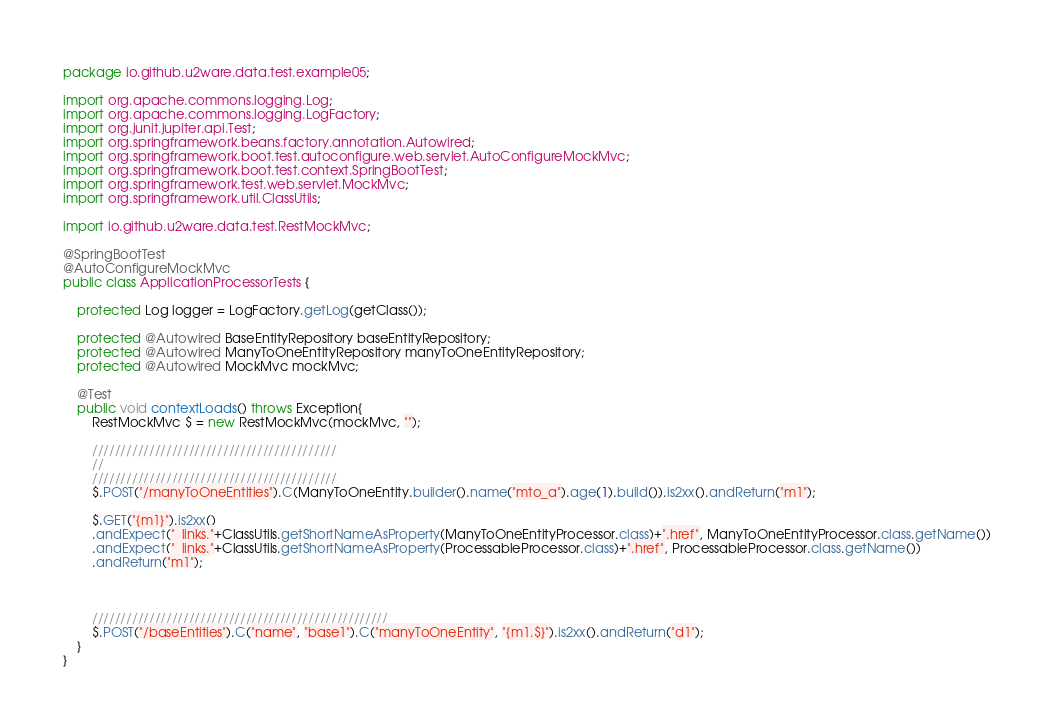Convert code to text. <code><loc_0><loc_0><loc_500><loc_500><_Java_>package io.github.u2ware.data.test.example05;

import org.apache.commons.logging.Log;
import org.apache.commons.logging.LogFactory;
import org.junit.jupiter.api.Test;
import org.springframework.beans.factory.annotation.Autowired;
import org.springframework.boot.test.autoconfigure.web.servlet.AutoConfigureMockMvc;
import org.springframework.boot.test.context.SpringBootTest;
import org.springframework.test.web.servlet.MockMvc;
import org.springframework.util.ClassUtils;

import io.github.u2ware.data.test.RestMockMvc;

@SpringBootTest
@AutoConfigureMockMvc
public class ApplicationProcessorTests {

	protected Log logger = LogFactory.getLog(getClass());

	protected @Autowired BaseEntityRepository baseEntityRepository;
	protected @Autowired ManyToOneEntityRepository manyToOneEntityRepository;
	protected @Autowired MockMvc mockMvc;

	@Test
	public void contextLoads() throws Exception{
		RestMockMvc $ = new RestMockMvc(mockMvc, "");

		///////////////////////////////////////////
		//
		///////////////////////////////////////////
		$.POST("/manyToOneEntities").C(ManyToOneEntity.builder().name("mto_a").age(1).build()).is2xx().andReturn("m1");

		$.GET("{m1}").is2xx()
		.andExpect("_links."+ClassUtils.getShortNameAsProperty(ManyToOneEntityProcessor.class)+".href", ManyToOneEntityProcessor.class.getName())
		.andExpect("_links."+ClassUtils.getShortNameAsProperty(ProcessableProcessor.class)+".href", ProcessableProcessor.class.getName())
		.andReturn("m1");
		

		
		////////////////////////////////////////////////////
		$.POST("/baseEntities").C("name", "base1").C("manyToOneEntity", "{m1.$}").is2xx().andReturn("d1");
	}	
}


</code> 